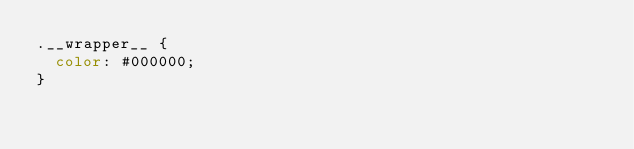<code> <loc_0><loc_0><loc_500><loc_500><_CSS_>.__wrapper__ {
  color: #000000;
}</code> 